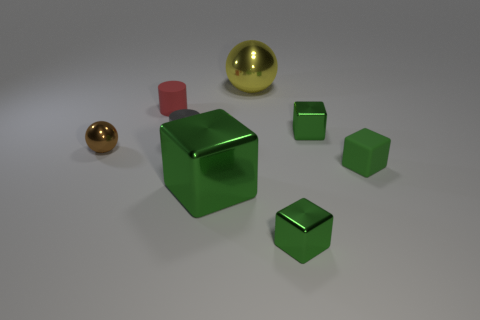How many green blocks must be subtracted to get 2 green blocks? 2 Subtract all matte cubes. How many cubes are left? 3 Subtract 2 blocks. How many blocks are left? 2 Add 2 big gray rubber objects. How many objects exist? 10 Subtract all yellow spheres. How many spheres are left? 1 Subtract all spheres. How many objects are left? 6 Add 4 shiny blocks. How many shiny blocks are left? 7 Add 5 tiny green cubes. How many tiny green cubes exist? 8 Subtract 0 yellow cylinders. How many objects are left? 8 Subtract all blue balls. Subtract all yellow cylinders. How many balls are left? 2 